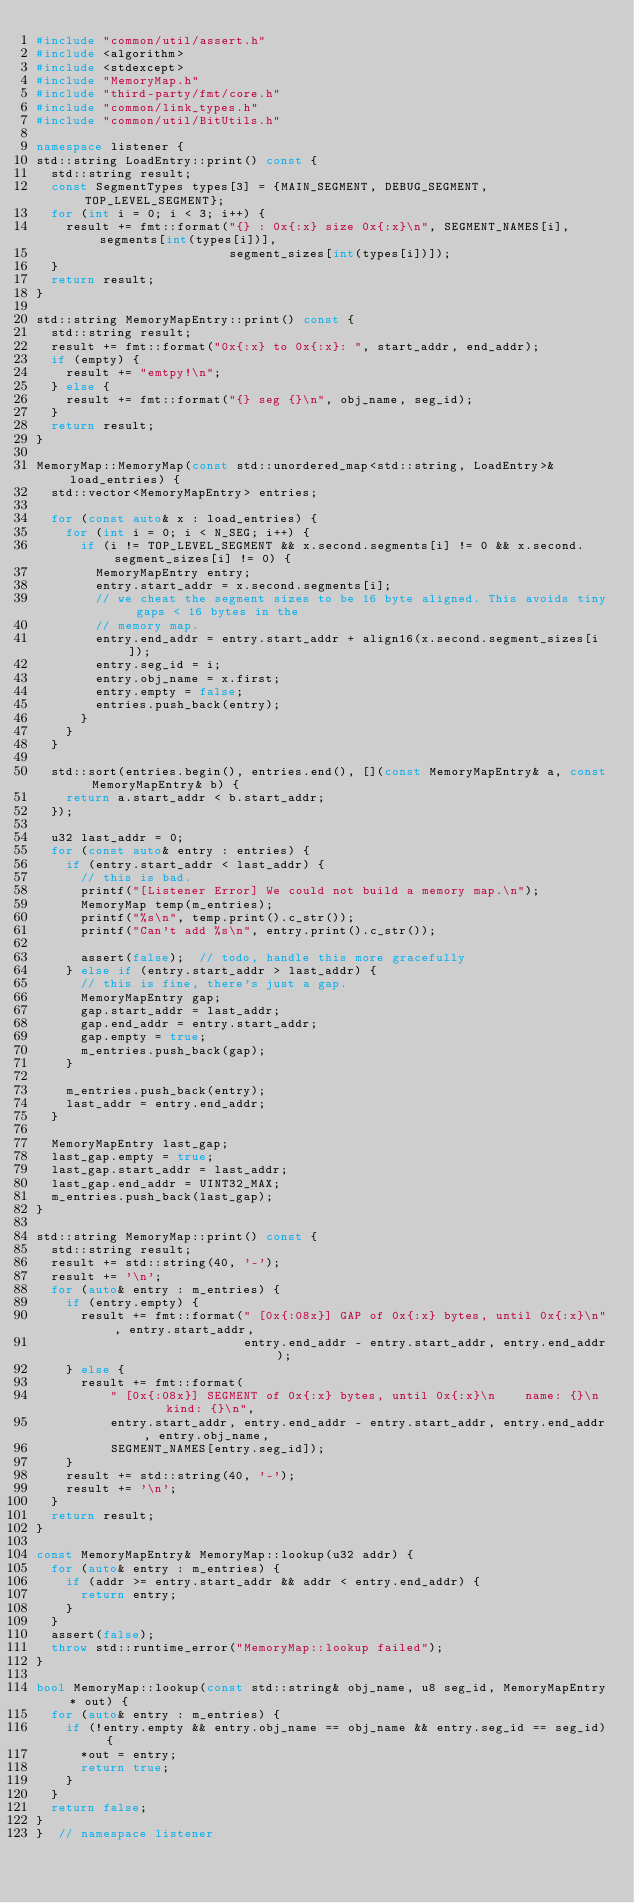<code> <loc_0><loc_0><loc_500><loc_500><_C++_>#include "common/util/assert.h"
#include <algorithm>
#include <stdexcept>
#include "MemoryMap.h"
#include "third-party/fmt/core.h"
#include "common/link_types.h"
#include "common/util/BitUtils.h"

namespace listener {
std::string LoadEntry::print() const {
  std::string result;
  const SegmentTypes types[3] = {MAIN_SEGMENT, DEBUG_SEGMENT, TOP_LEVEL_SEGMENT};
  for (int i = 0; i < 3; i++) {
    result += fmt::format("{} : 0x{:x} size 0x{:x}\n", SEGMENT_NAMES[i], segments[int(types[i])],
                          segment_sizes[int(types[i])]);
  }
  return result;
}

std::string MemoryMapEntry::print() const {
  std::string result;
  result += fmt::format("0x{:x} to 0x{:x}: ", start_addr, end_addr);
  if (empty) {
    result += "emtpy!\n";
  } else {
    result += fmt::format("{} seg {}\n", obj_name, seg_id);
  }
  return result;
}

MemoryMap::MemoryMap(const std::unordered_map<std::string, LoadEntry>& load_entries) {
  std::vector<MemoryMapEntry> entries;

  for (const auto& x : load_entries) {
    for (int i = 0; i < N_SEG; i++) {
      if (i != TOP_LEVEL_SEGMENT && x.second.segments[i] != 0 && x.second.segment_sizes[i] != 0) {
        MemoryMapEntry entry;
        entry.start_addr = x.second.segments[i];
        // we cheat the segment sizes to be 16 byte aligned. This avoids tiny gaps < 16 bytes in the
        // memory map.
        entry.end_addr = entry.start_addr + align16(x.second.segment_sizes[i]);
        entry.seg_id = i;
        entry.obj_name = x.first;
        entry.empty = false;
        entries.push_back(entry);
      }
    }
  }

  std::sort(entries.begin(), entries.end(), [](const MemoryMapEntry& a, const MemoryMapEntry& b) {
    return a.start_addr < b.start_addr;
  });

  u32 last_addr = 0;
  for (const auto& entry : entries) {
    if (entry.start_addr < last_addr) {
      // this is bad.
      printf("[Listener Error] We could not build a memory map.\n");
      MemoryMap temp(m_entries);
      printf("%s\n", temp.print().c_str());
      printf("Can't add %s\n", entry.print().c_str());

      assert(false);  // todo, handle this more gracefully
    } else if (entry.start_addr > last_addr) {
      // this is fine, there's just a gap.
      MemoryMapEntry gap;
      gap.start_addr = last_addr;
      gap.end_addr = entry.start_addr;
      gap.empty = true;
      m_entries.push_back(gap);
    }

    m_entries.push_back(entry);
    last_addr = entry.end_addr;
  }

  MemoryMapEntry last_gap;
  last_gap.empty = true;
  last_gap.start_addr = last_addr;
  last_gap.end_addr = UINT32_MAX;
  m_entries.push_back(last_gap);
}

std::string MemoryMap::print() const {
  std::string result;
  result += std::string(40, '-');
  result += '\n';
  for (auto& entry : m_entries) {
    if (entry.empty) {
      result += fmt::format(" [0x{:08x}] GAP of 0x{:x} bytes, until 0x{:x}\n", entry.start_addr,
                            entry.end_addr - entry.start_addr, entry.end_addr);
    } else {
      result += fmt::format(
          " [0x{:08x}] SEGMENT of 0x{:x} bytes, until 0x{:x}\n    name: {}\n    kind: {}\n",
          entry.start_addr, entry.end_addr - entry.start_addr, entry.end_addr, entry.obj_name,
          SEGMENT_NAMES[entry.seg_id]);
    }
    result += std::string(40, '-');
    result += '\n';
  }
  return result;
}

const MemoryMapEntry& MemoryMap::lookup(u32 addr) {
  for (auto& entry : m_entries) {
    if (addr >= entry.start_addr && addr < entry.end_addr) {
      return entry;
    }
  }
  assert(false);
  throw std::runtime_error("MemoryMap::lookup failed");
}

bool MemoryMap::lookup(const std::string& obj_name, u8 seg_id, MemoryMapEntry* out) {
  for (auto& entry : m_entries) {
    if (!entry.empty && entry.obj_name == obj_name && entry.seg_id == seg_id) {
      *out = entry;
      return true;
    }
  }
  return false;
}
}  // namespace listener</code> 